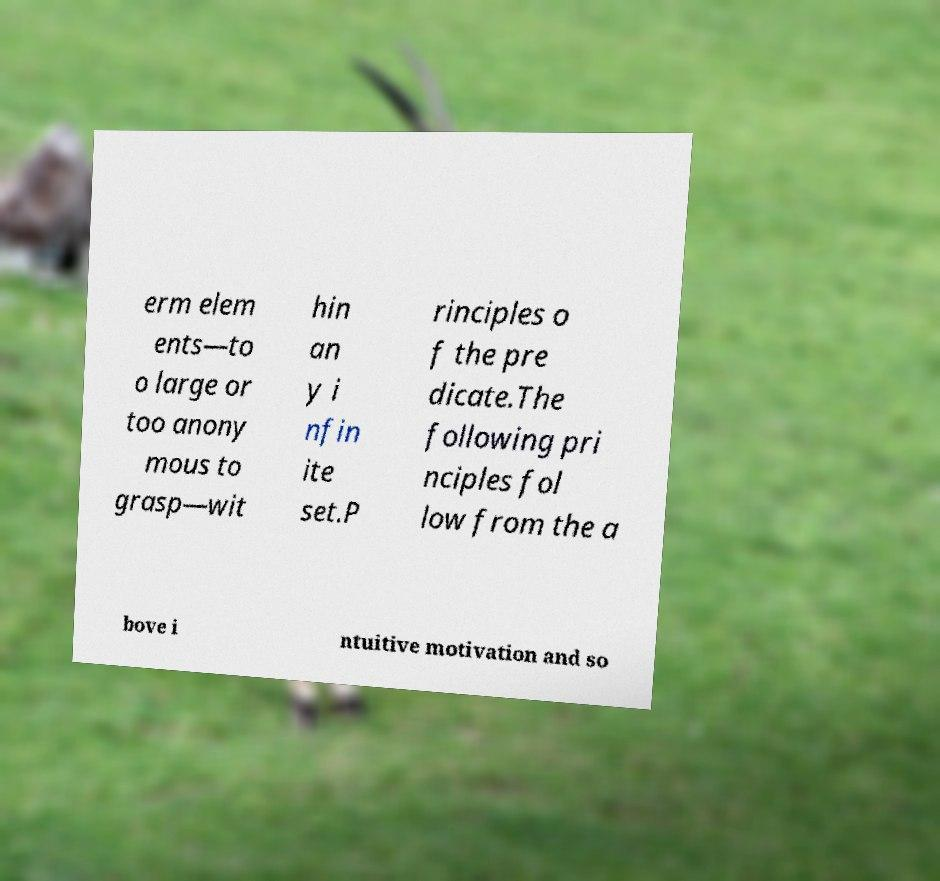Can you read and provide the text displayed in the image?This photo seems to have some interesting text. Can you extract and type it out for me? erm elem ents—to o large or too anony mous to grasp—wit hin an y i nfin ite set.P rinciples o f the pre dicate.The following pri nciples fol low from the a bove i ntuitive motivation and so 